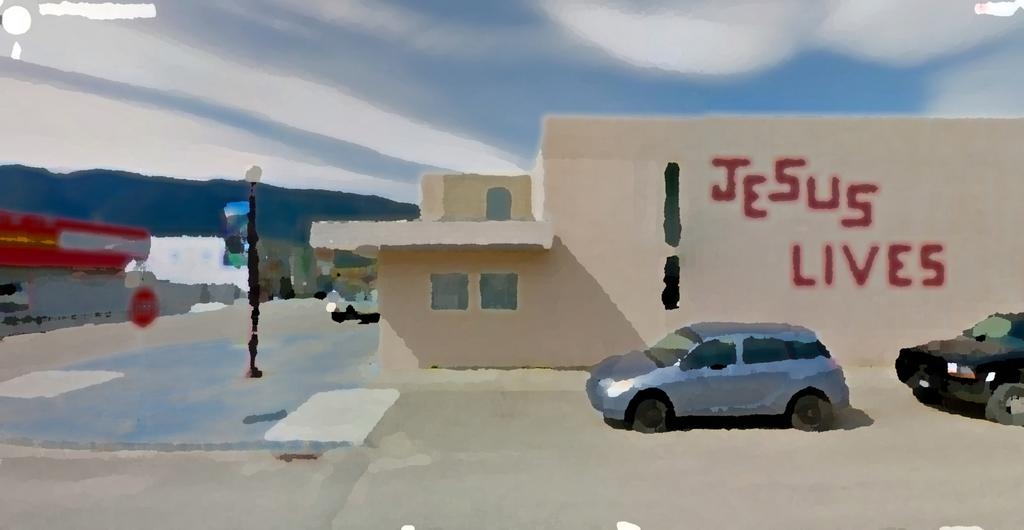What is the main subject of the image? The image contains a painting. What else can be seen in the image besides the painting? There are buildings, cars, a pole, and text on the wall of a building visible in the image. What is the condition of the sky in the image? The sky is blue and cloudy in the image. What type of bells can be heard ringing in the image? There are no bells present in the image, and therefore no sound can be heard. What is the crate used for in the image? There is no crate present in the image. 